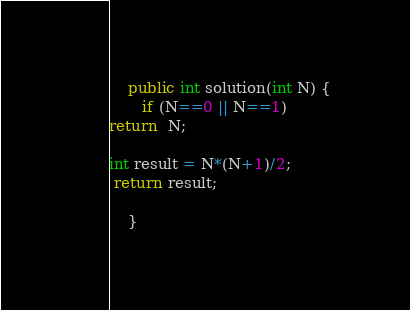<code> <loc_0><loc_0><loc_500><loc_500><_C#_>    public int solution(int N) {
       if (N==0 || N==1)
return  N;

int result = N*(N+1)/2;
 return result;
         
    }</code> 